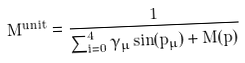<formula> <loc_0><loc_0><loc_500><loc_500>M ^ { u n i t } = \frac { 1 } { \sum _ { i = 0 } ^ { 4 } \gamma _ { \mu } \sin ( p _ { \mu } ) + M ( p ) }</formula> 